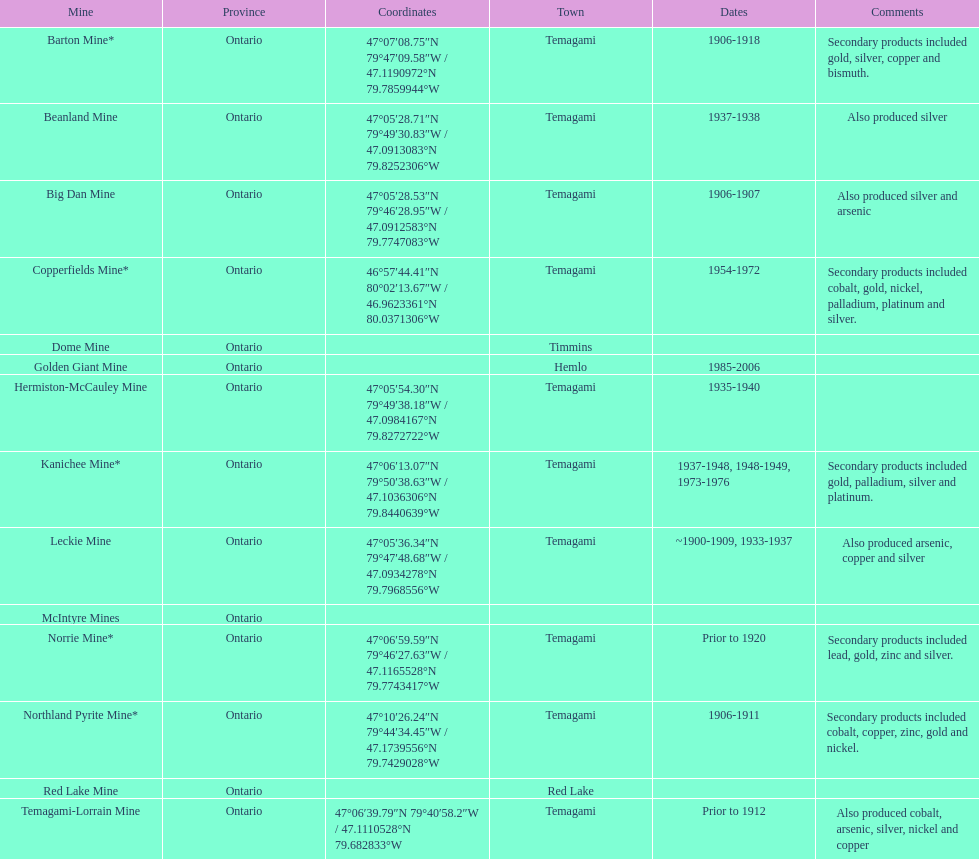Which town is referred to the most? Temagami. 